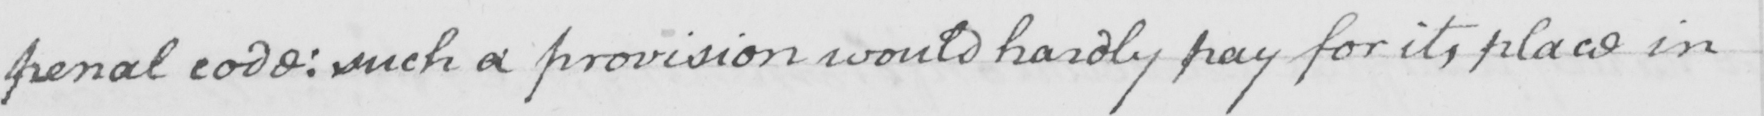Can you read and transcribe this handwriting? penal code :  such a provision would hardly pay for its place in 